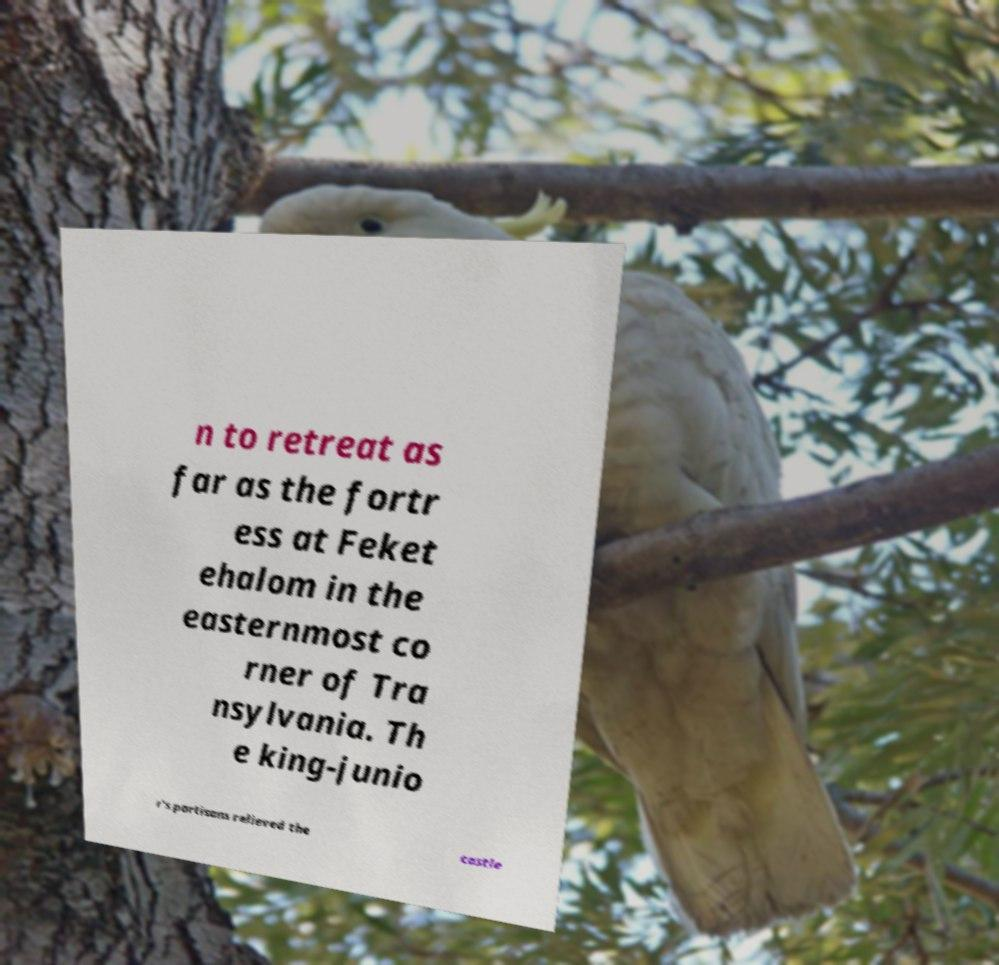What messages or text are displayed in this image? I need them in a readable, typed format. n to retreat as far as the fortr ess at Feket ehalom in the easternmost co rner of Tra nsylvania. Th e king-junio r's partisans relieved the castle 